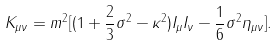<formula> <loc_0><loc_0><loc_500><loc_500>K _ { \mu \nu } = m ^ { 2 } [ ( 1 + \frac { 2 } { 3 } \sigma ^ { 2 } - \kappa ^ { 2 } ) I _ { \mu } I _ { \nu } - \frac { 1 } { 6 } \sigma ^ { 2 } \eta _ { \mu \nu } ] .</formula> 